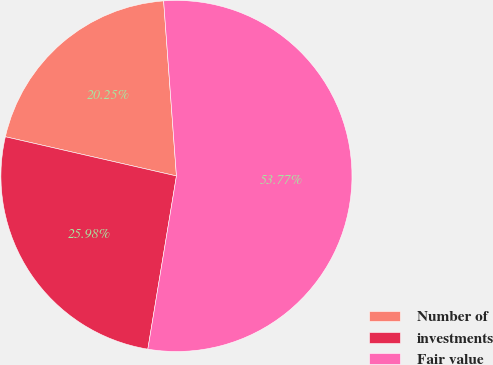Convert chart to OTSL. <chart><loc_0><loc_0><loc_500><loc_500><pie_chart><fcel>Number of<fcel>investments<fcel>Fair value<nl><fcel>20.25%<fcel>25.98%<fcel>53.77%<nl></chart> 